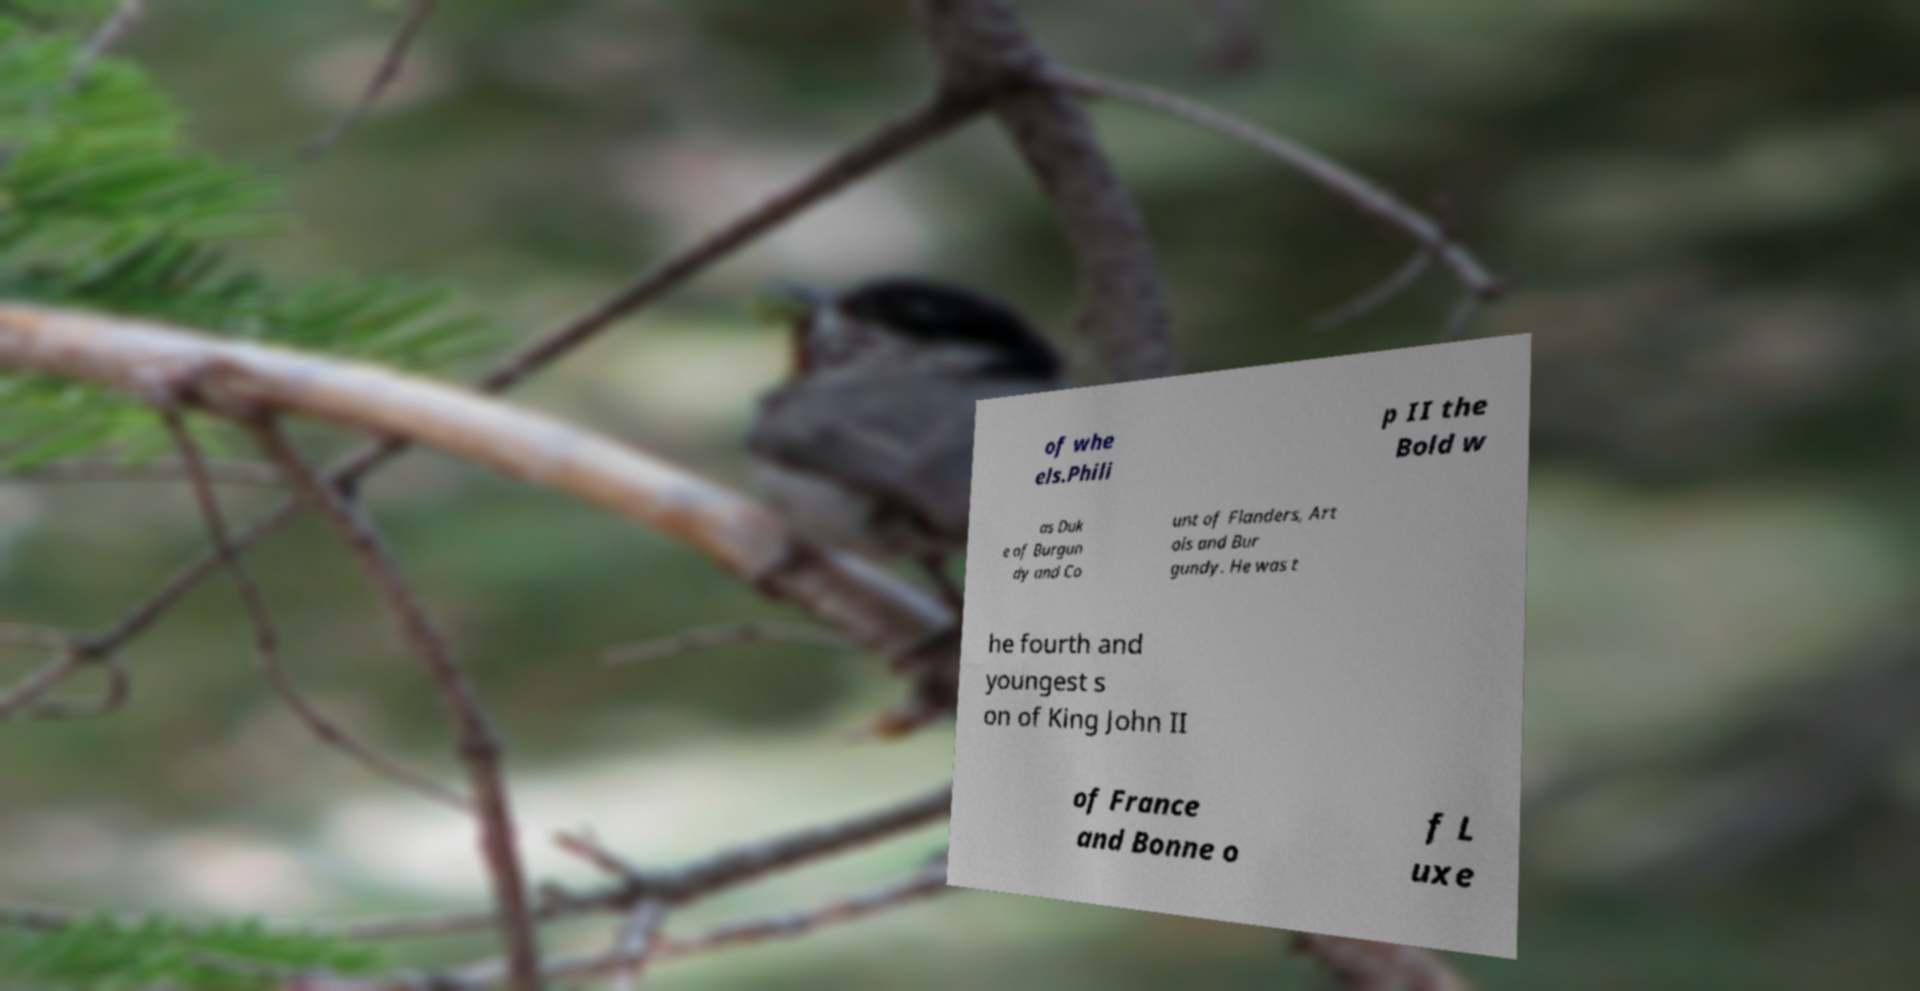I need the written content from this picture converted into text. Can you do that? of whe els.Phili p II the Bold w as Duk e of Burgun dy and Co unt of Flanders, Art ois and Bur gundy. He was t he fourth and youngest s on of King John II of France and Bonne o f L uxe 